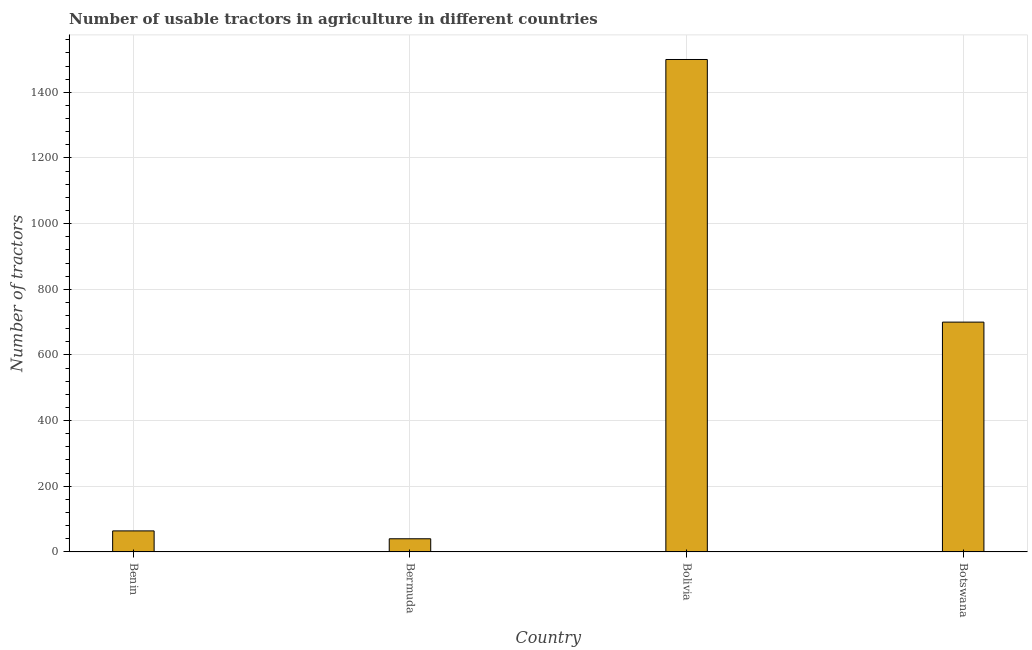Does the graph contain any zero values?
Give a very brief answer. No. Does the graph contain grids?
Keep it short and to the point. Yes. What is the title of the graph?
Provide a succinct answer. Number of usable tractors in agriculture in different countries. What is the label or title of the Y-axis?
Keep it short and to the point. Number of tractors. Across all countries, what is the maximum number of tractors?
Your response must be concise. 1500. In which country was the number of tractors minimum?
Your answer should be very brief. Bermuda. What is the sum of the number of tractors?
Ensure brevity in your answer.  2304. What is the average number of tractors per country?
Ensure brevity in your answer.  576. What is the median number of tractors?
Provide a short and direct response. 382. In how many countries, is the number of tractors greater than 1160 ?
Keep it short and to the point. 1. What is the ratio of the number of tractors in Bolivia to that in Botswana?
Offer a very short reply. 2.14. What is the difference between the highest and the second highest number of tractors?
Your answer should be very brief. 800. Is the sum of the number of tractors in Benin and Botswana greater than the maximum number of tractors across all countries?
Make the answer very short. No. What is the difference between the highest and the lowest number of tractors?
Provide a succinct answer. 1460. How many bars are there?
Your answer should be very brief. 4. Are all the bars in the graph horizontal?
Offer a terse response. No. Are the values on the major ticks of Y-axis written in scientific E-notation?
Your answer should be compact. No. What is the Number of tractors of Benin?
Make the answer very short. 64. What is the Number of tractors of Bermuda?
Your answer should be very brief. 40. What is the Number of tractors of Bolivia?
Make the answer very short. 1500. What is the Number of tractors in Botswana?
Offer a terse response. 700. What is the difference between the Number of tractors in Benin and Bermuda?
Offer a very short reply. 24. What is the difference between the Number of tractors in Benin and Bolivia?
Ensure brevity in your answer.  -1436. What is the difference between the Number of tractors in Benin and Botswana?
Provide a succinct answer. -636. What is the difference between the Number of tractors in Bermuda and Bolivia?
Offer a very short reply. -1460. What is the difference between the Number of tractors in Bermuda and Botswana?
Make the answer very short. -660. What is the difference between the Number of tractors in Bolivia and Botswana?
Give a very brief answer. 800. What is the ratio of the Number of tractors in Benin to that in Bermuda?
Keep it short and to the point. 1.6. What is the ratio of the Number of tractors in Benin to that in Bolivia?
Offer a terse response. 0.04. What is the ratio of the Number of tractors in Benin to that in Botswana?
Your answer should be very brief. 0.09. What is the ratio of the Number of tractors in Bermuda to that in Bolivia?
Keep it short and to the point. 0.03. What is the ratio of the Number of tractors in Bermuda to that in Botswana?
Your answer should be very brief. 0.06. What is the ratio of the Number of tractors in Bolivia to that in Botswana?
Provide a short and direct response. 2.14. 